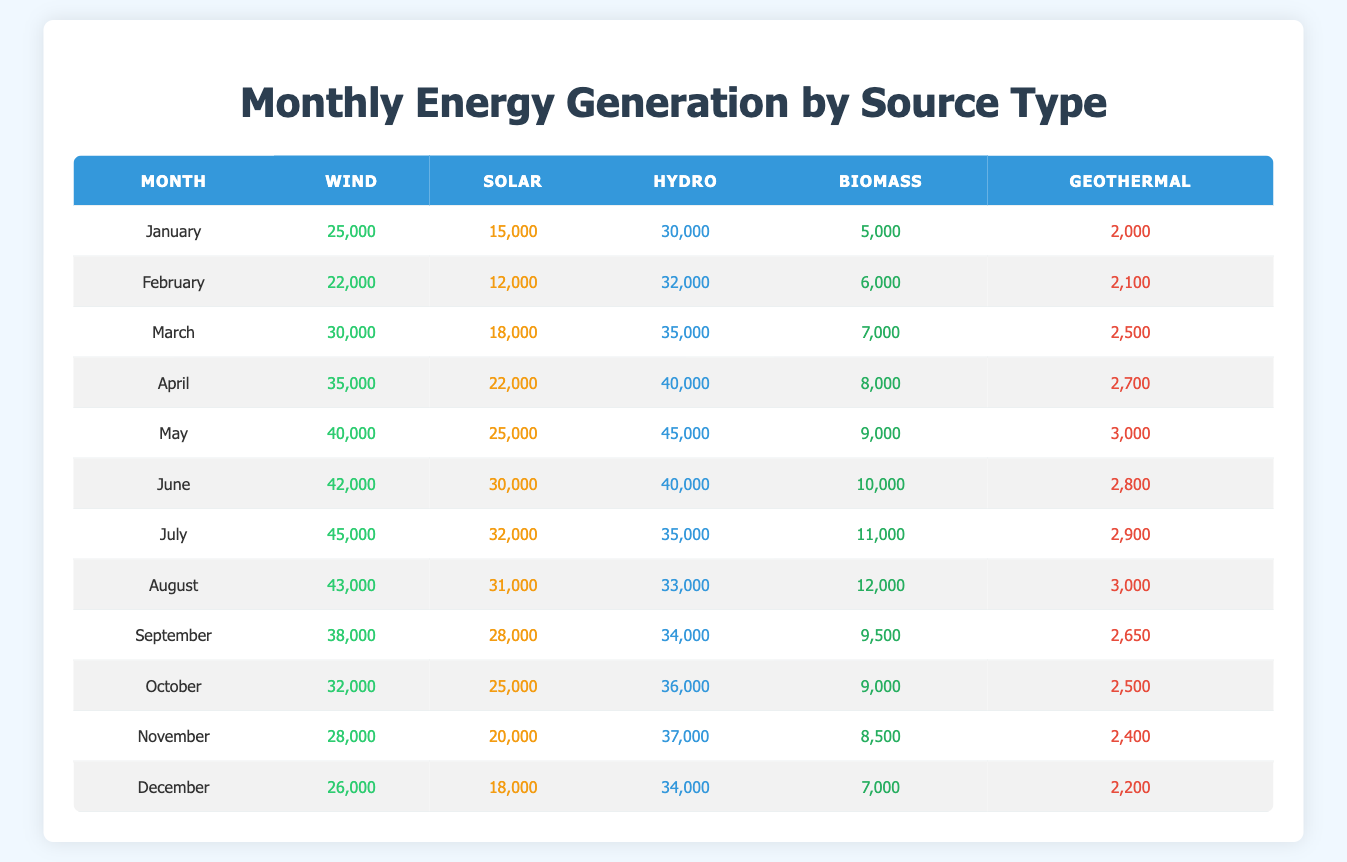What is the total energy generation from hydro in May? In May, the value for hydro energy generation is 45,000. Since we're only interested in that month's value, we take it directly from the table.
Answer: 45,000 Which month had the lowest biomass generation? By looking at the biomass values for each month, the lowest value is in January with 5,000. We confirm this by scanning the list for the minimum.
Answer: January What is the average wind energy generation across all months? First, we add all the wind values: 25,000 + 22,000 + 30,000 + 35,000 + 40,000 + 42,000 + 45,000 + 43,000 + 38,000 + 32,000 + 28,000 + 26,000 =  487,000. We then divide by the number of months, which is 12, calculating 487,000/12 = 40,583.33.
Answer: 40,583.33 In which month did biomass generation exceed 10,000? Scanning the biomass values, we note that biomass generation first exceeds 10,000 in July with a value of 11,000. We confirm by checking the preceding months to ensure July is the first occurrence where the value exceeds that threshold.
Answer: July Was the solar energy generation greater than 20,000 in all months? Looking at the solar values, we see that in January and February, the generation is below 20,000, specifically 15,000 and 12,000, respectively. Therefore, it's false that solar energy generation was above 20,000 in every month.
Answer: No What is the total energy generation from all sources in December? We need to sum the values for each source in December: Wind (26,000) + Solar (18,000) + Hydro (34,000) + Biomass (7,000) + Geothermal (2,200) = 87,200. We ensure we calculate the total accurately by verifying each row’s value in December.
Answer: 87,200 During which month was there a decrease in hydro generation compared to the previous month? Observing the hydro values, we find that from June (40,000) to July (35,000), there is a drop. We check each month sequentially and confirm that this is the only decrease observed when comparing consecutive months.
Answer: July What is the range of wind energy generation across all months? To find the range, we determine the maximum wind generation of 45,000 (July) and the minimum of 22,000 (February). The range is calculated as max - min = 45,000 - 22,000 = 23,000.
Answer: 23,000 